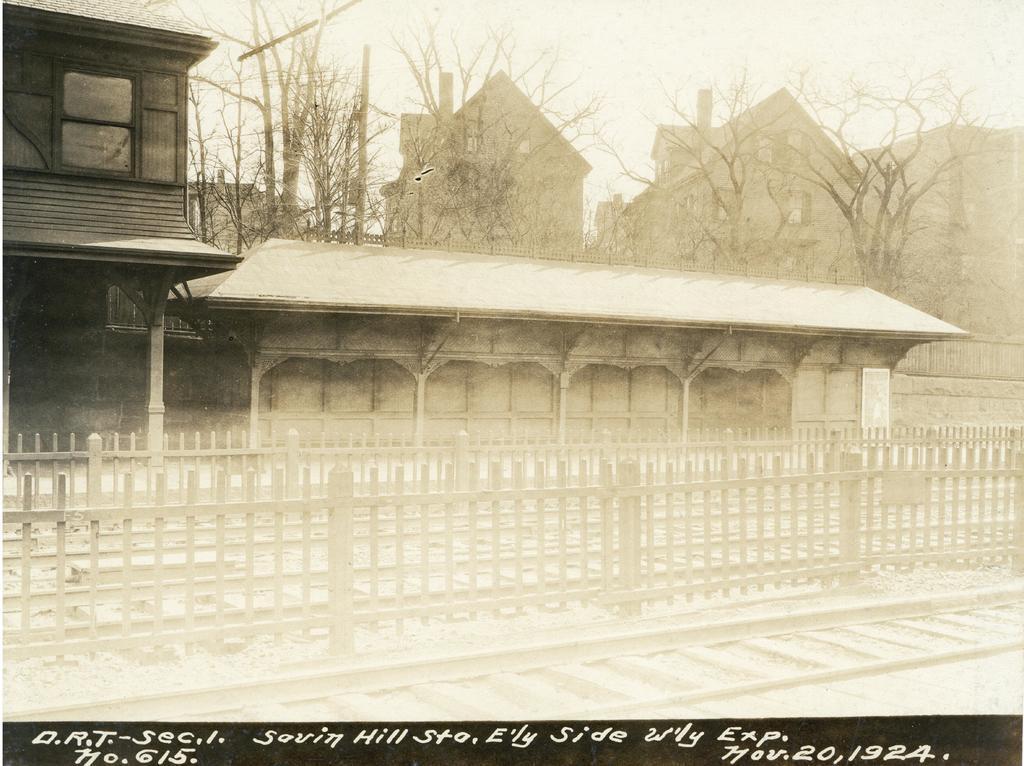In one or two sentences, can you explain what this image depicts? In this image there are buildings. In the front of the buildings there are the wooden railings. At the bottom there are railway tracks. Behind the buildings there are trees. At the top there is the sky. Below the picture there is text on the image. 